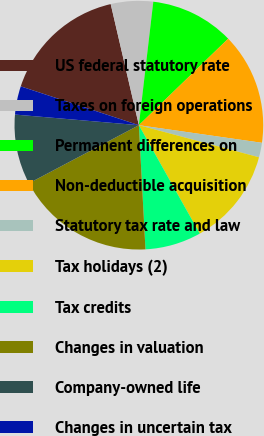Convert chart. <chart><loc_0><loc_0><loc_500><loc_500><pie_chart><fcel>US federal statutory rate<fcel>Taxes on foreign operations<fcel>Permanent differences on<fcel>Non-deductible acquisition<fcel>Statutory tax rate and law<fcel>Tax holidays (2)<fcel>Tax credits<fcel>Changes in valuation<fcel>Company-owned life<fcel>Changes in uncertain tax<nl><fcel>16.31%<fcel>5.49%<fcel>10.9%<fcel>14.51%<fcel>1.89%<fcel>12.7%<fcel>7.3%<fcel>18.11%<fcel>9.1%<fcel>3.69%<nl></chart> 